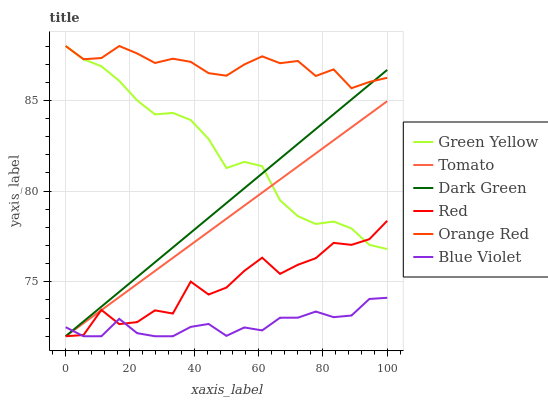Does Blue Violet have the minimum area under the curve?
Answer yes or no. Yes. Does Orange Red have the maximum area under the curve?
Answer yes or no. Yes. Does Red have the minimum area under the curve?
Answer yes or no. No. Does Red have the maximum area under the curve?
Answer yes or no. No. Is Dark Green the smoothest?
Answer yes or no. Yes. Is Red the roughest?
Answer yes or no. Yes. Is Green Yellow the smoothest?
Answer yes or no. No. Is Green Yellow the roughest?
Answer yes or no. No. Does Tomato have the lowest value?
Answer yes or no. Yes. Does Green Yellow have the lowest value?
Answer yes or no. No. Does Orange Red have the highest value?
Answer yes or no. Yes. Does Red have the highest value?
Answer yes or no. No. Is Blue Violet less than Orange Red?
Answer yes or no. Yes. Is Orange Red greater than Tomato?
Answer yes or no. Yes. Does Tomato intersect Red?
Answer yes or no. Yes. Is Tomato less than Red?
Answer yes or no. No. Is Tomato greater than Red?
Answer yes or no. No. Does Blue Violet intersect Orange Red?
Answer yes or no. No. 